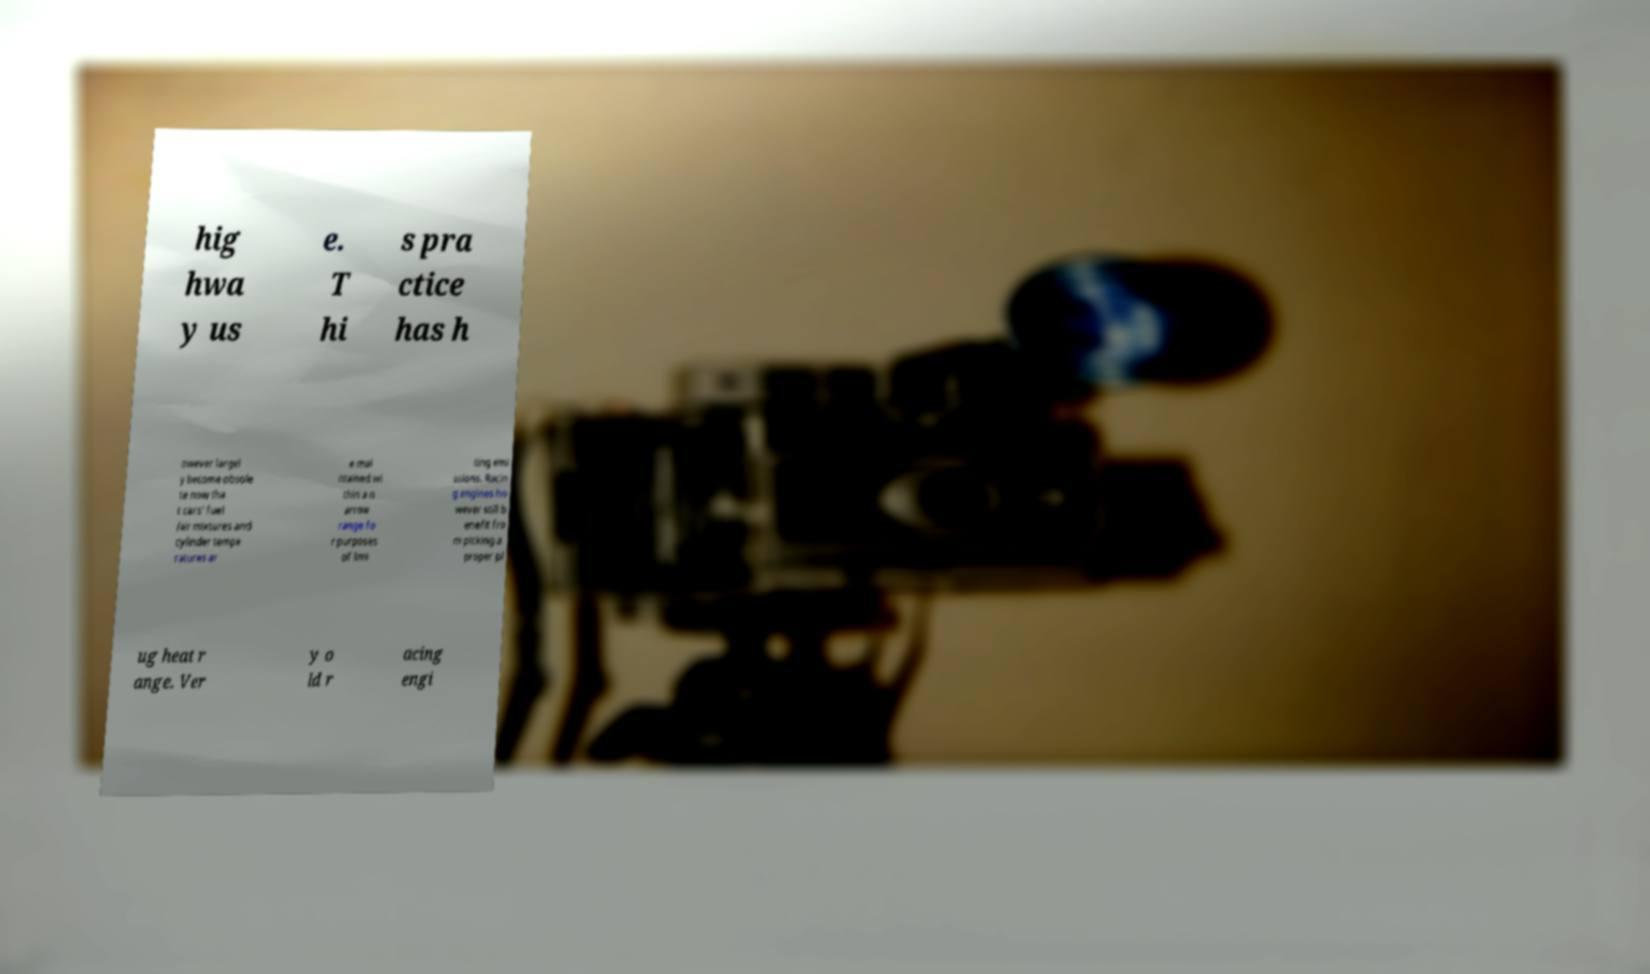Please identify and transcribe the text found in this image. hig hwa y us e. T hi s pra ctice has h owever largel y become obsole te now tha t cars' fuel /air mixtures and cylinder tempe ratures ar e mai ntained wi thin a n arrow range fo r purposes of limi ting emi ssions. Racin g engines ho wever still b enefit fro m picking a proper pl ug heat r ange. Ver y o ld r acing engi 